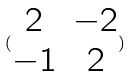Convert formula to latex. <formula><loc_0><loc_0><loc_500><loc_500>( \begin{matrix} 2 & - 2 \\ - 1 & 2 \end{matrix} )</formula> 